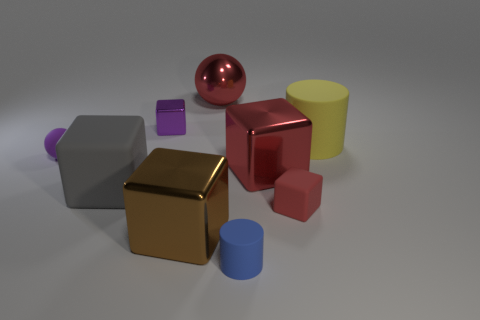There is a red metallic object that is behind the tiny shiny thing behind the rubber cube that is right of the large red sphere; what is its size?
Ensure brevity in your answer.  Large. Are there fewer small red rubber things than large things?
Give a very brief answer. Yes. What color is the other small object that is the same shape as the tiny red rubber thing?
Your answer should be compact. Purple. Are there any purple objects that are in front of the large object that is behind the cylinder behind the tiny purple ball?
Provide a succinct answer. Yes. Do the small purple matte object and the small blue object have the same shape?
Give a very brief answer. No. Are there fewer tiny balls that are to the left of the purple sphere than big yellow matte things?
Your answer should be compact. Yes. There is a rubber cylinder in front of the big rubber thing that is to the right of the rubber cylinder that is in front of the brown shiny thing; what color is it?
Ensure brevity in your answer.  Blue. How many rubber objects are yellow cylinders or large cyan things?
Your response must be concise. 1. Is the metallic sphere the same size as the purple ball?
Ensure brevity in your answer.  No. Are there fewer matte objects that are on the right side of the small purple sphere than shiny objects that are to the right of the tiny purple cube?
Ensure brevity in your answer.  No. 